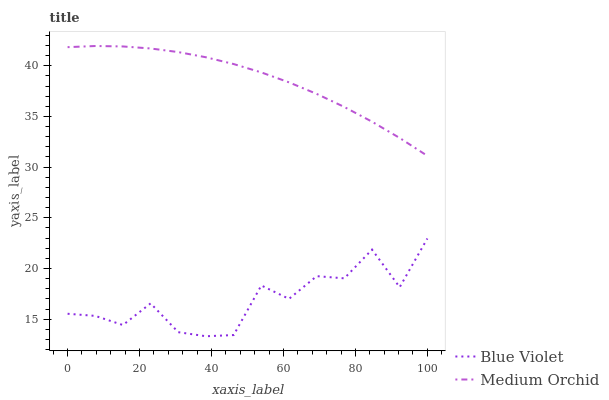Does Blue Violet have the minimum area under the curve?
Answer yes or no. Yes. Does Medium Orchid have the maximum area under the curve?
Answer yes or no. Yes. Does Blue Violet have the maximum area under the curve?
Answer yes or no. No. Is Medium Orchid the smoothest?
Answer yes or no. Yes. Is Blue Violet the roughest?
Answer yes or no. Yes. Is Blue Violet the smoothest?
Answer yes or no. No. Does Blue Violet have the lowest value?
Answer yes or no. Yes. Does Medium Orchid have the highest value?
Answer yes or no. Yes. Does Blue Violet have the highest value?
Answer yes or no. No. Is Blue Violet less than Medium Orchid?
Answer yes or no. Yes. Is Medium Orchid greater than Blue Violet?
Answer yes or no. Yes. Does Blue Violet intersect Medium Orchid?
Answer yes or no. No. 